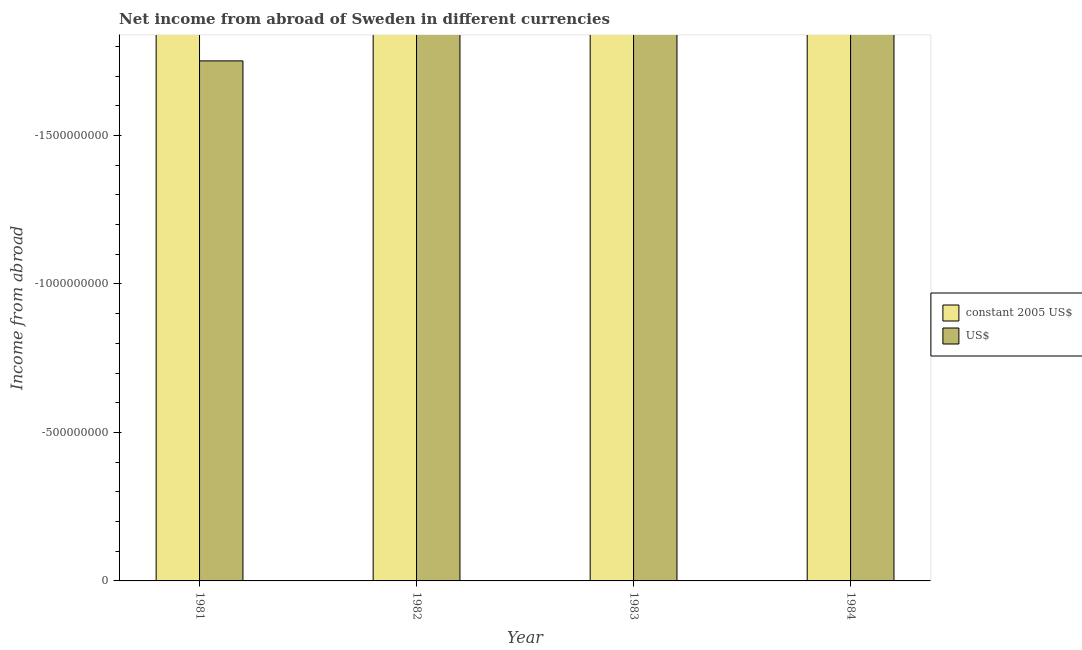How many different coloured bars are there?
Ensure brevity in your answer.  0. How many bars are there on the 1st tick from the right?
Offer a terse response. 0. What is the label of the 2nd group of bars from the left?
Provide a short and direct response. 1982. In how many cases, is the number of bars for a given year not equal to the number of legend labels?
Ensure brevity in your answer.  4. Across all years, what is the minimum income from abroad in constant 2005 us$?
Keep it short and to the point. 0. What is the average income from abroad in constant 2005 us$ per year?
Keep it short and to the point. 0. In how many years, is the income from abroad in constant 2005 us$ greater than the average income from abroad in constant 2005 us$ taken over all years?
Offer a very short reply. 0. How many bars are there?
Your answer should be very brief. 0. Are all the bars in the graph horizontal?
Offer a terse response. No. What is the difference between two consecutive major ticks on the Y-axis?
Your answer should be compact. 5.00e+08. Does the graph contain any zero values?
Offer a terse response. Yes. How are the legend labels stacked?
Offer a very short reply. Vertical. What is the title of the graph?
Make the answer very short. Net income from abroad of Sweden in different currencies. Does "Tetanus" appear as one of the legend labels in the graph?
Your answer should be compact. No. What is the label or title of the X-axis?
Make the answer very short. Year. What is the label or title of the Y-axis?
Ensure brevity in your answer.  Income from abroad. What is the Income from abroad in US$ in 1983?
Ensure brevity in your answer.  0. What is the Income from abroad in constant 2005 US$ in 1984?
Offer a terse response. 0. What is the total Income from abroad in constant 2005 US$ in the graph?
Offer a very short reply. 0. What is the total Income from abroad in US$ in the graph?
Your answer should be very brief. 0. 